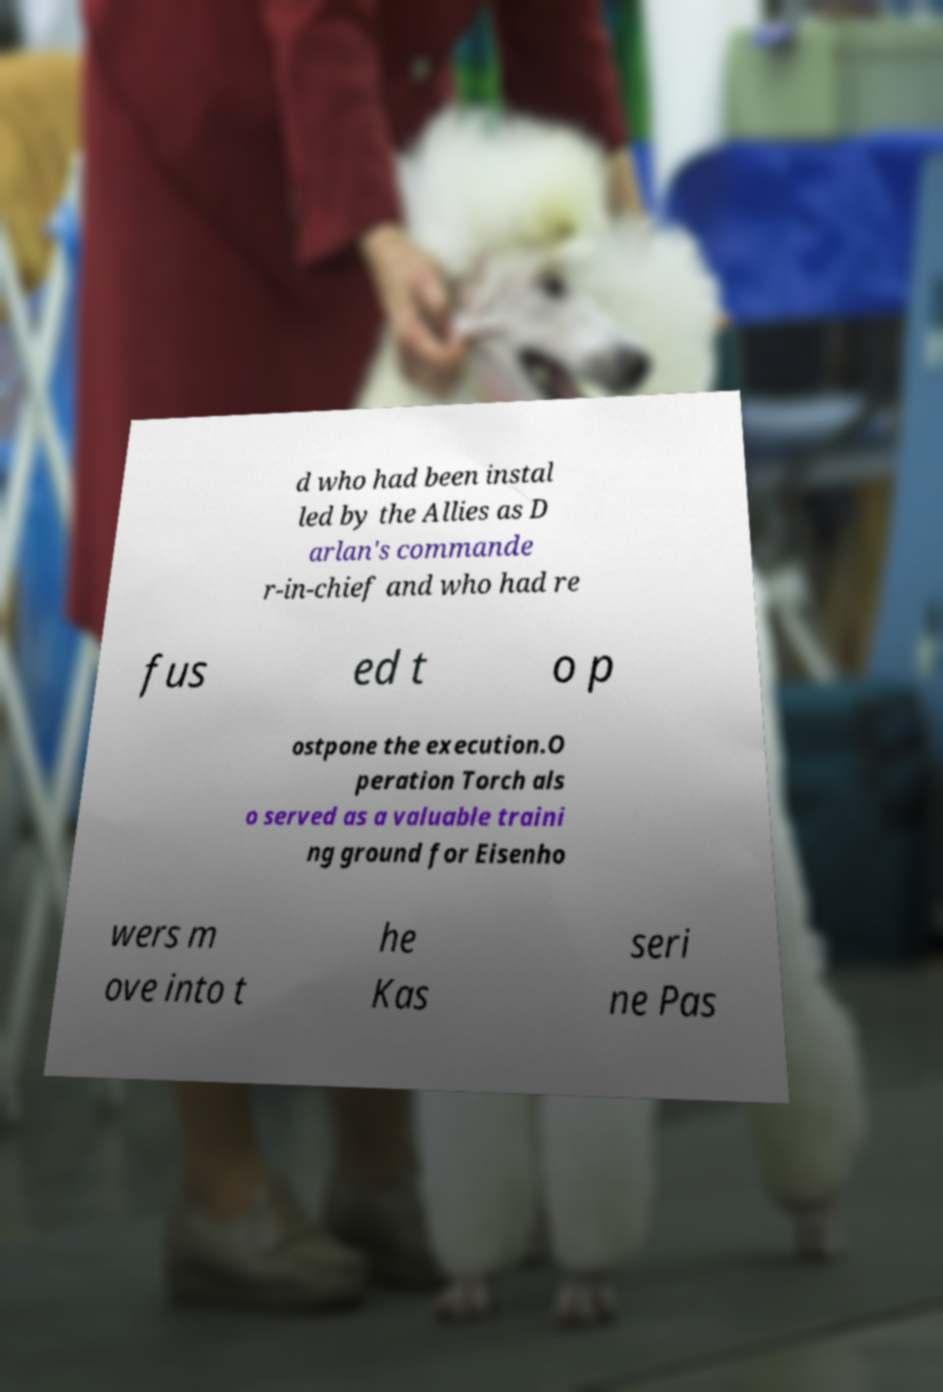Can you read and provide the text displayed in the image?This photo seems to have some interesting text. Can you extract and type it out for me? d who had been instal led by the Allies as D arlan's commande r-in-chief and who had re fus ed t o p ostpone the execution.O peration Torch als o served as a valuable traini ng ground for Eisenho wers m ove into t he Kas seri ne Pas 